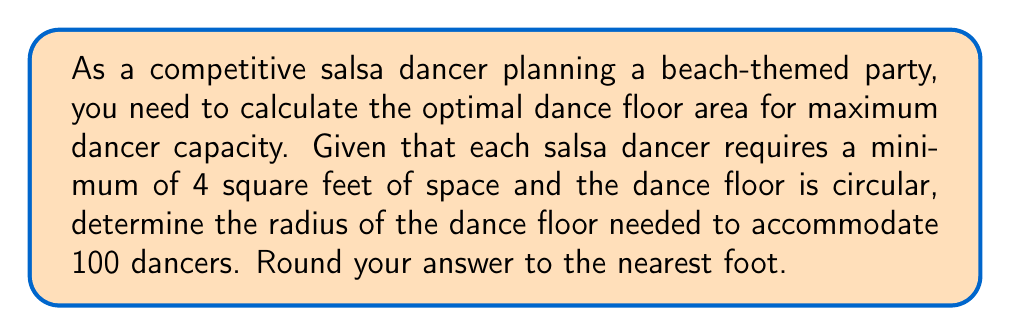What is the answer to this math problem? Let's approach this step-by-step:

1) First, we need to calculate the total area required for 100 dancers:
   $$ \text{Total Area} = 100 \text{ dancers} \times 4 \text{ sq ft/dancer} = 400 \text{ sq ft} $$

2) Now, we know that the dance floor is circular. The area of a circle is given by the formula:
   $$ A = \pi r^2 $$
   where $A$ is the area and $r$ is the radius.

3) We can set up an equation:
   $$ 400 = \pi r^2 $$

4) To solve for $r$, we divide both sides by $\pi$ and then take the square root:
   $$ r^2 = \frac{400}{\pi} $$
   $$ r = \sqrt{\frac{400}{\pi}} $$

5) Let's calculate this:
   $$ r = \sqrt{\frac{400}{3.14159}} \approx 11.28 \text{ feet} $$

6) Rounding to the nearest foot:
   $$ r \approx 11 \text{ feet} $$

Therefore, the optimal radius for the circular dance floor is approximately 11 feet.
Answer: 11 feet 